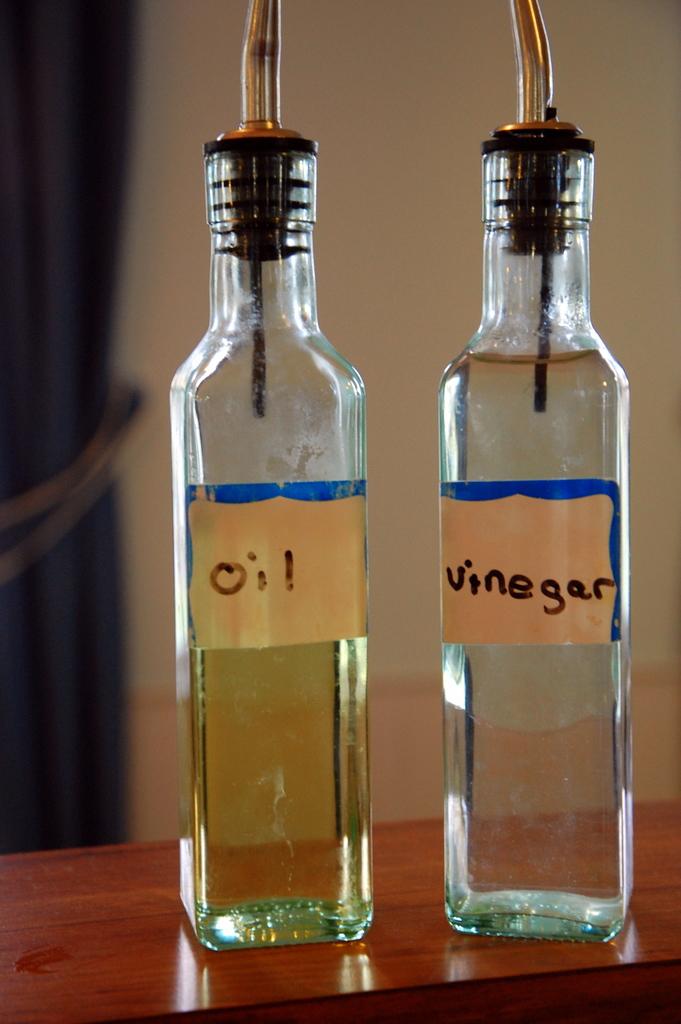What's in the left jar?
Your answer should be very brief. Oil. What type of liquid is in the right bottle?
Your answer should be compact. Vinegar. 